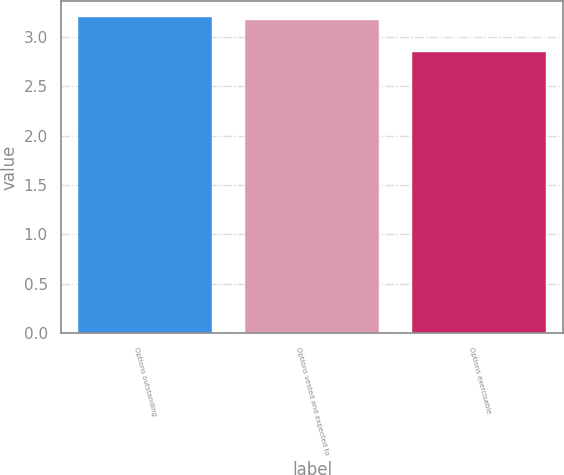<chart> <loc_0><loc_0><loc_500><loc_500><bar_chart><fcel>Options outstanding<fcel>Options vested and expected to<fcel>Options exercisable<nl><fcel>3.2<fcel>3.17<fcel>2.85<nl></chart> 